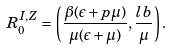<formula> <loc_0><loc_0><loc_500><loc_500>R _ { 0 } ^ { I , Z } = \left ( \frac { \beta ( \epsilon + p \mu ) } { \mu ( \epsilon + \mu ) } , \frac { l b } { \mu } \right ) .</formula> 